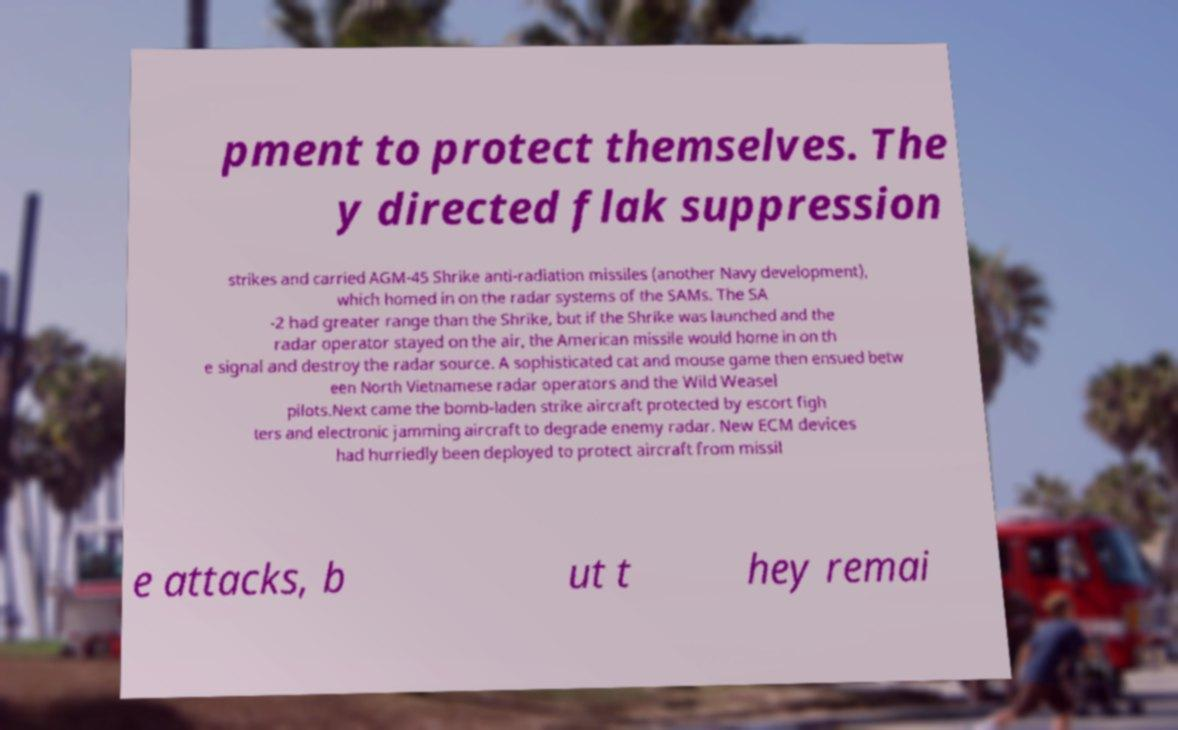Could you assist in decoding the text presented in this image and type it out clearly? pment to protect themselves. The y directed flak suppression strikes and carried AGM-45 Shrike anti-radiation missiles (another Navy development), which homed in on the radar systems of the SAMs. The SA -2 had greater range than the Shrike, but if the Shrike was launched and the radar operator stayed on the air, the American missile would home in on th e signal and destroy the radar source. A sophisticated cat and mouse game then ensued betw een North Vietnamese radar operators and the Wild Weasel pilots.Next came the bomb-laden strike aircraft protected by escort figh ters and electronic jamming aircraft to degrade enemy radar. New ECM devices had hurriedly been deployed to protect aircraft from missil e attacks, b ut t hey remai 